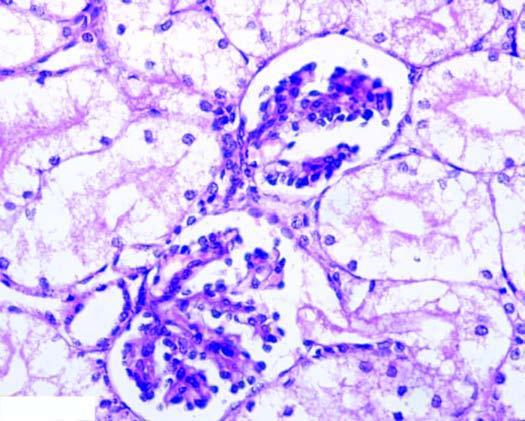re the tubular epithelial cells distended with cytoplasmic vacuoles while the interstitial vasculature is compressed?
Answer the question using a single word or phrase. Yes 